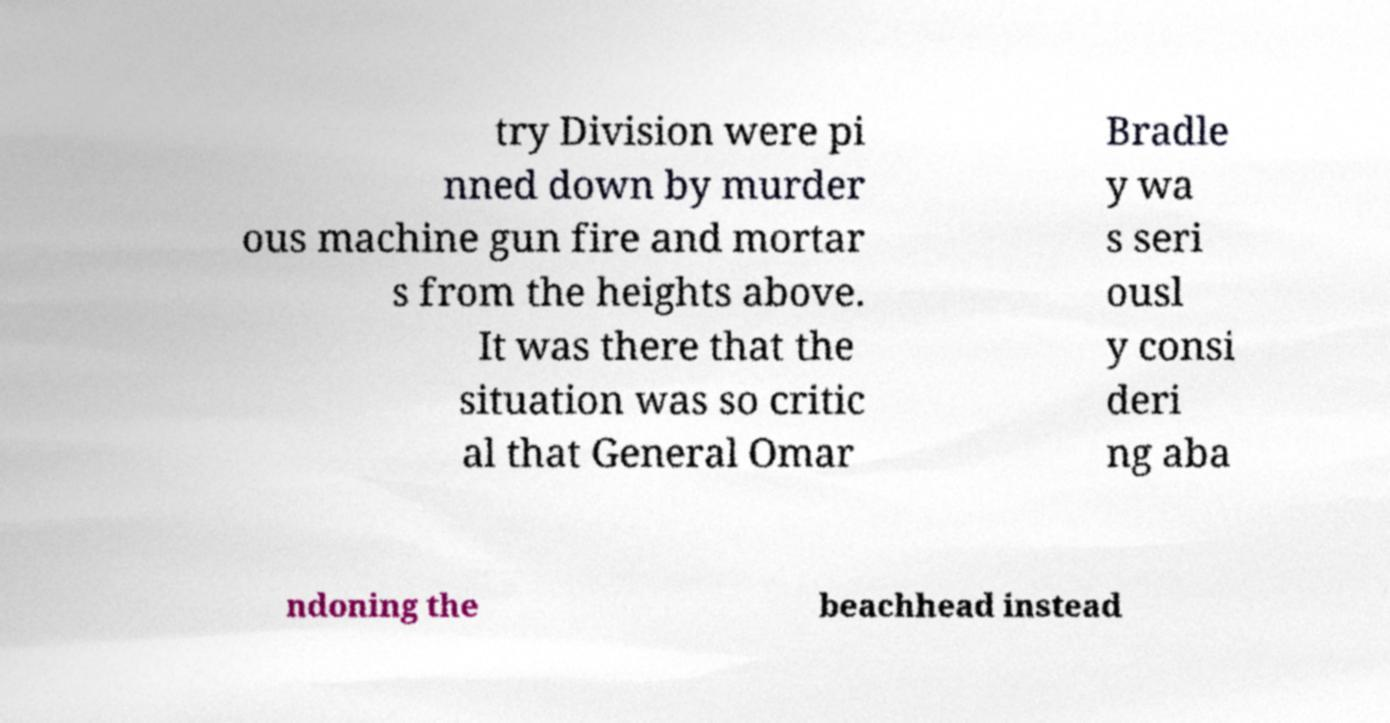Could you extract and type out the text from this image? try Division were pi nned down by murder ous machine gun fire and mortar s from the heights above. It was there that the situation was so critic al that General Omar Bradle y wa s seri ousl y consi deri ng aba ndoning the beachhead instead 